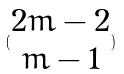Convert formula to latex. <formula><loc_0><loc_0><loc_500><loc_500>( \begin{matrix} 2 m - 2 \\ m - 1 \end{matrix} )</formula> 